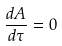Convert formula to latex. <formula><loc_0><loc_0><loc_500><loc_500>\frac { d A } { d \tau } = 0</formula> 